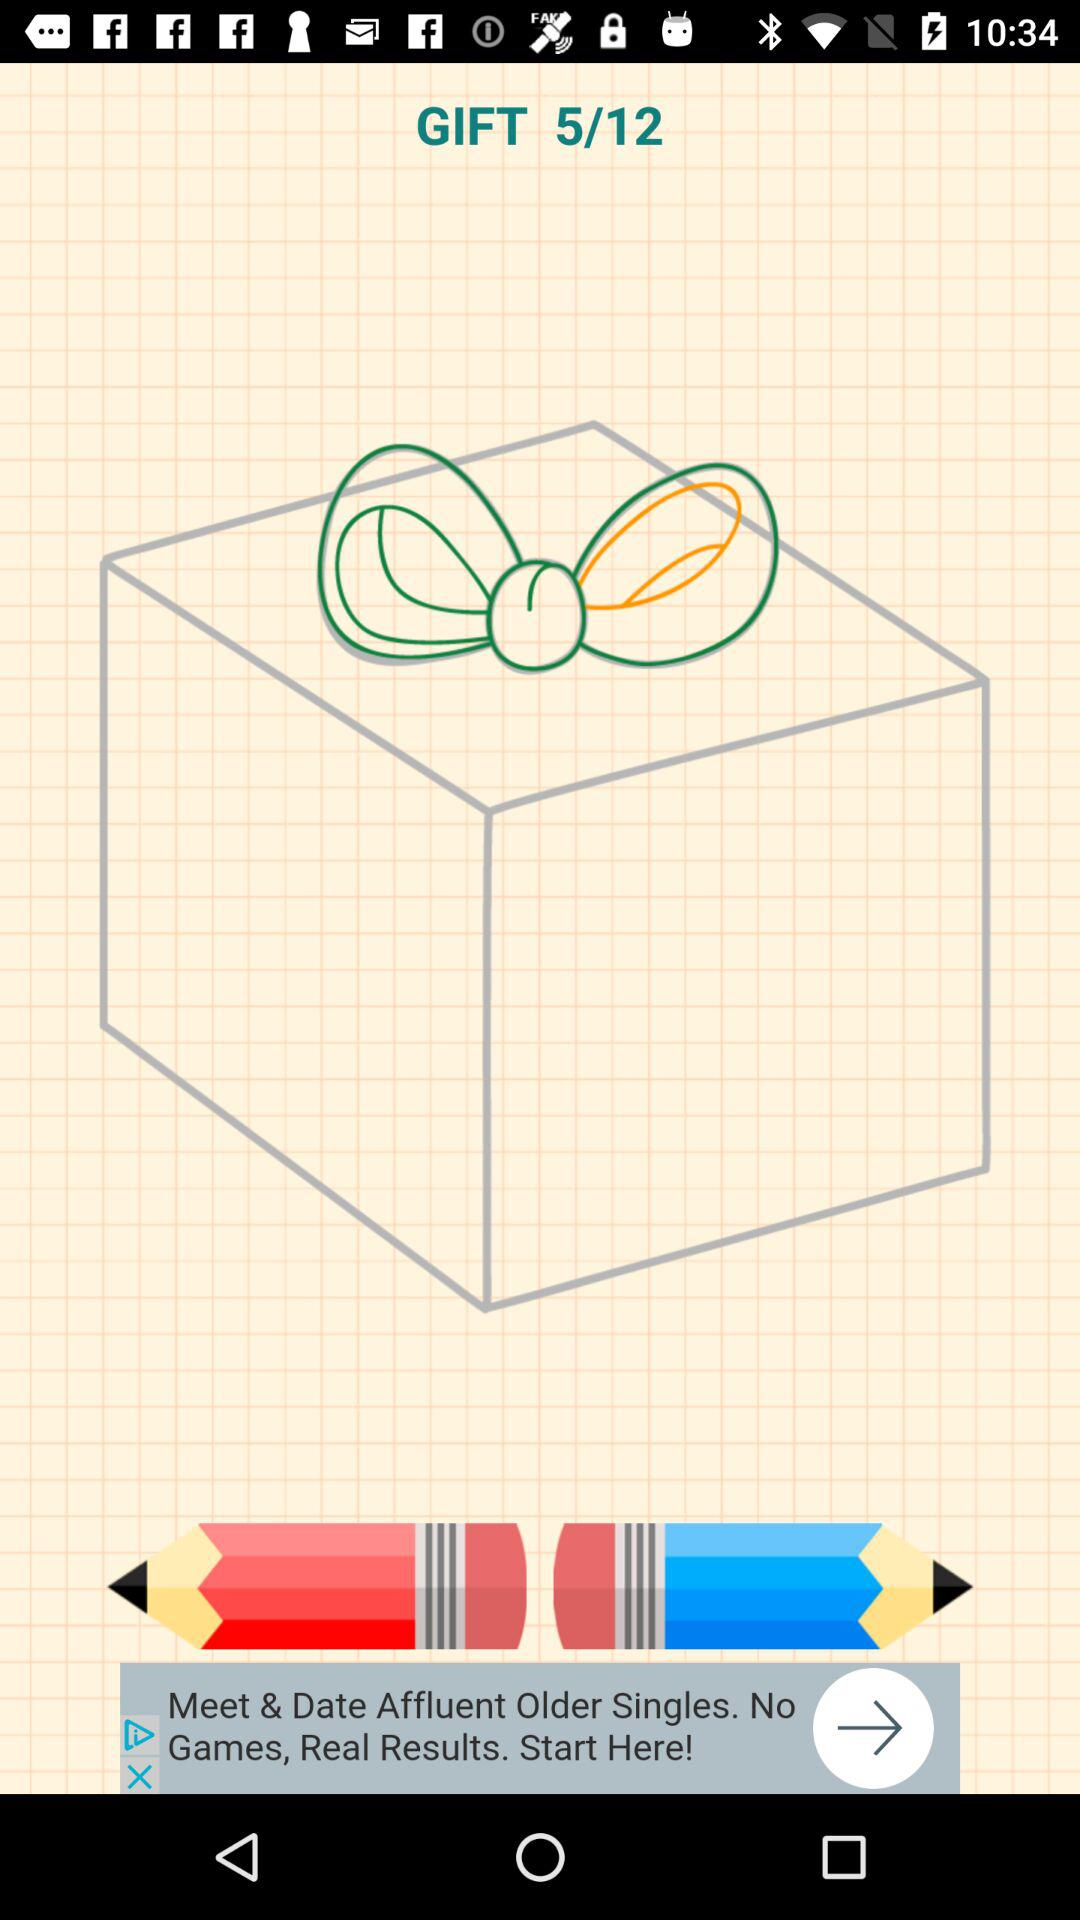What is the title of the image? The title of the image is "GIFT". 